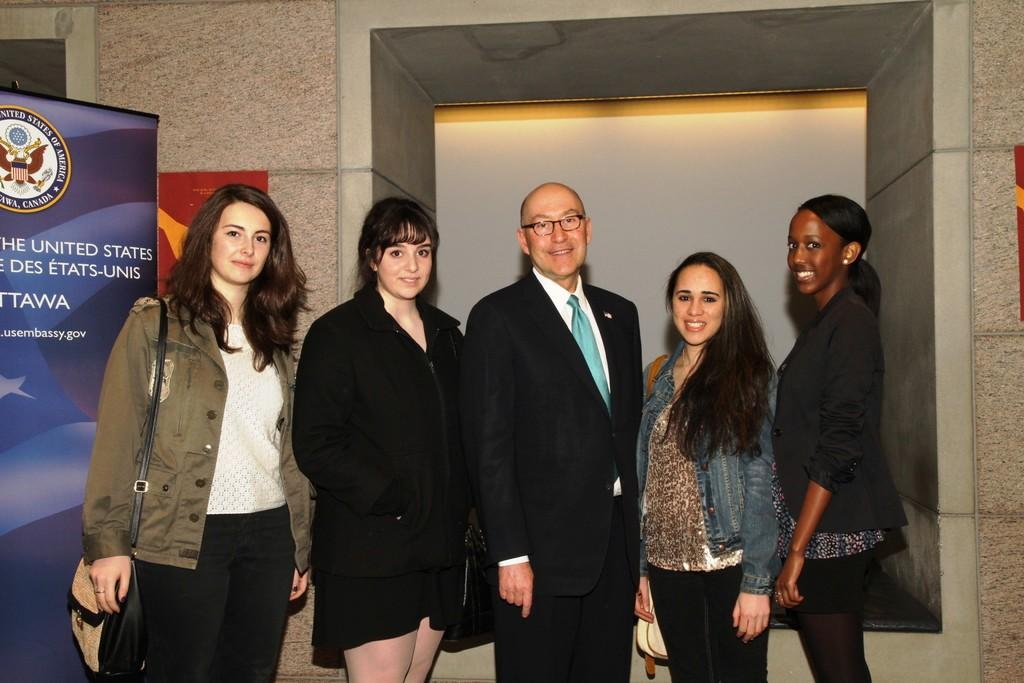What is happening in the middle of the image? There are people standing in the middle of the image. What is the facial expression of the people in the image? The people are smiling. What is located behind the people in the image? There is a banner behind the people. What is behind the banner in the image? There is a wall behind the banner. What type of wound can be seen on the banner in the image? There is no wound present on the banner in the image. What color is the gold engine in the image? There is no gold engine present in the image. 